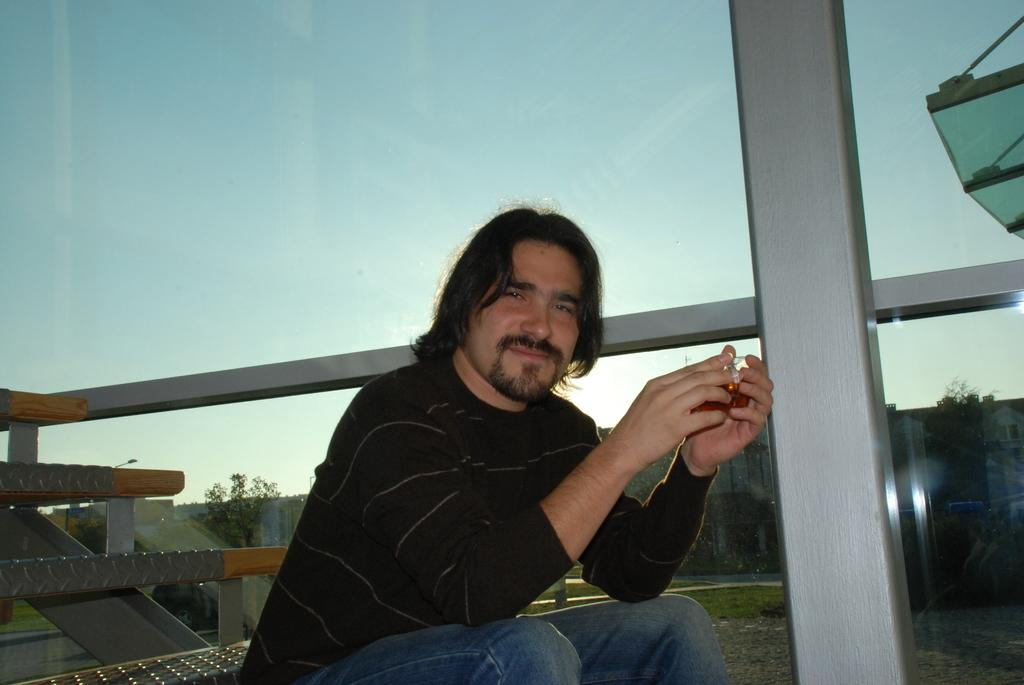Who is present in the image? There is a man in the image. What is the man doing in the image? The man is sitting on the stairs. What is the man's facial expression in the image? The man is smiling. What can be seen in the background of the image through the glass? Trees, buildings, and the sky are visible through the glass. What type of mark does the man leave on the stairs in the image? There is no indication in the image that the man leaves any mark on the stairs. 